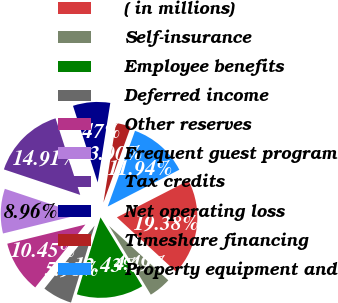Convert chart. <chart><loc_0><loc_0><loc_500><loc_500><pie_chart><fcel>( in millions)<fcel>Self-insurance<fcel>Employee benefits<fcel>Deferred income<fcel>Other reserves<fcel>Frequent guest program<fcel>Tax credits<fcel>Net operating loss<fcel>Timeshare financing<fcel>Property equipment and<nl><fcel>19.38%<fcel>4.49%<fcel>13.43%<fcel>5.98%<fcel>10.45%<fcel>8.96%<fcel>14.91%<fcel>7.47%<fcel>3.0%<fcel>11.94%<nl></chart> 